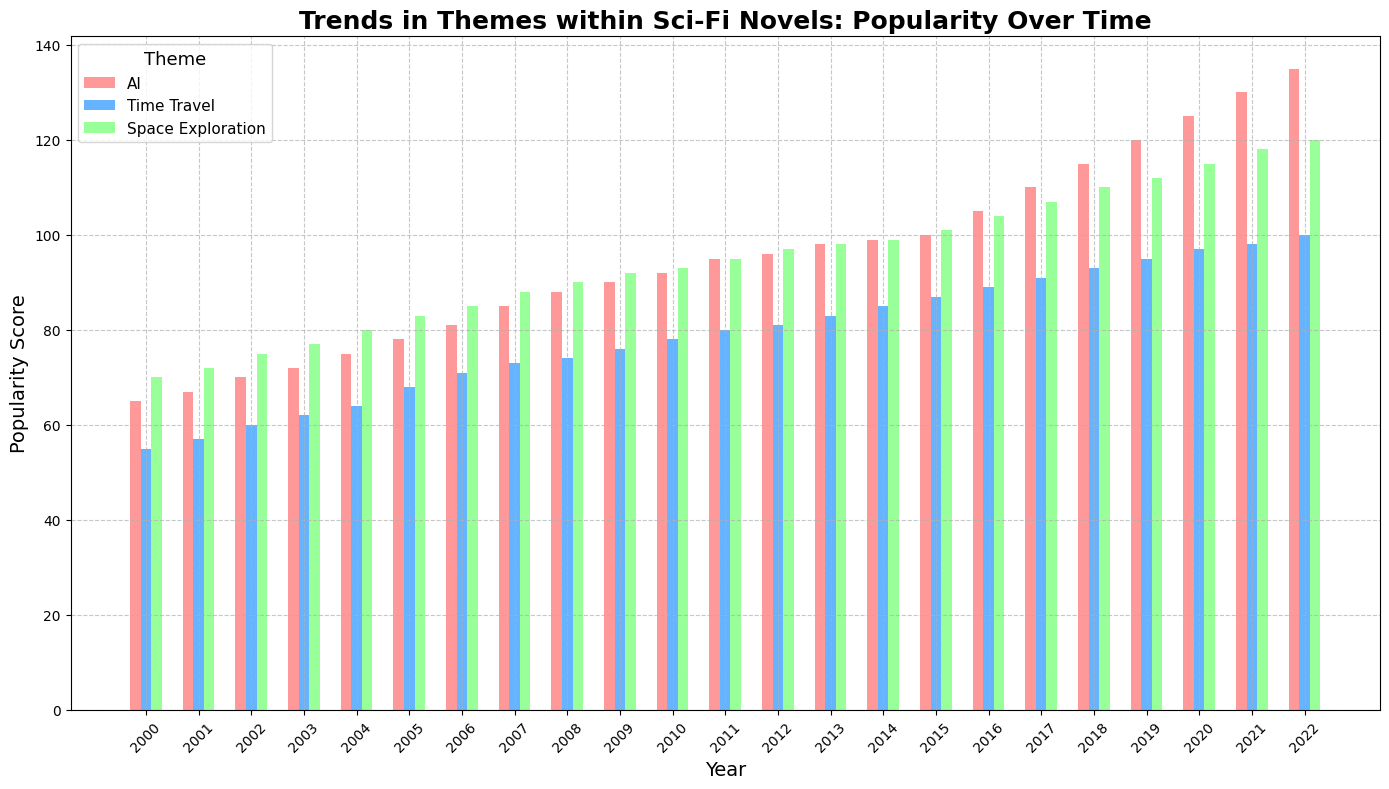Which theme saw the highest popularity score in 2022? By examining the plot, we observe that AI achieved the highest popularity score in 2022, depicted by the tallest bar for that year.
Answer: AI How did the popularity score of Time Travel change from 2000 to 2022? The popularity score of Time Travel in 2000 was 55, and it increased to 100 by 2022. The change can be found by subtracting 55 from 100.
Answer: 45 Which theme had the highest overall popularity score in 2005? By comparing the heights of the bars for each theme in 2005, Space Exploration had the highest score.
Answer: Space Exploration Between AI and Space Exploration, which theme had a higher popularity score in 2010 and by how much? In 2010, AI had a popularity score of 92 while Space Exploration had a score of 93. The difference is 1.
Answer: Space Exploration by 1 What was the average popularity score of Space Exploration in 2020 and 2021? The popularity score of Space Exploration in 2020 is 115 and in 2021 is 118. Their average is (115 + 118) / 2 = 116.5.
Answer: 116.5 Did AI surpass a popularity score of 120 before 2020? If yes, in which year? Observing AI's timeline, it surpassed a popularity score of 120 in 2019.
Answer: 2019 What is the total increase in popularity score of Space Exploration from 2005 to 2015? Space Exploration had a popularity score of 83 in 2005 and 101 in 2015. The total increase is 101 - 83 = 18.
Answer: 18 Which theme showed the least increase in popularity from 2000 to 2010? By comparing the changes over the decade, Time Travel increased from 55 to 78 (23 points), which is less than AI and Space Exploration.
Answer: Time Travel How much more popular was AI compared to Time Travel in 2022? In 2022, AI had a popularity score of 135 and Time Travel had 100. The difference is 135 - 100 = 35.
Answer: 35 